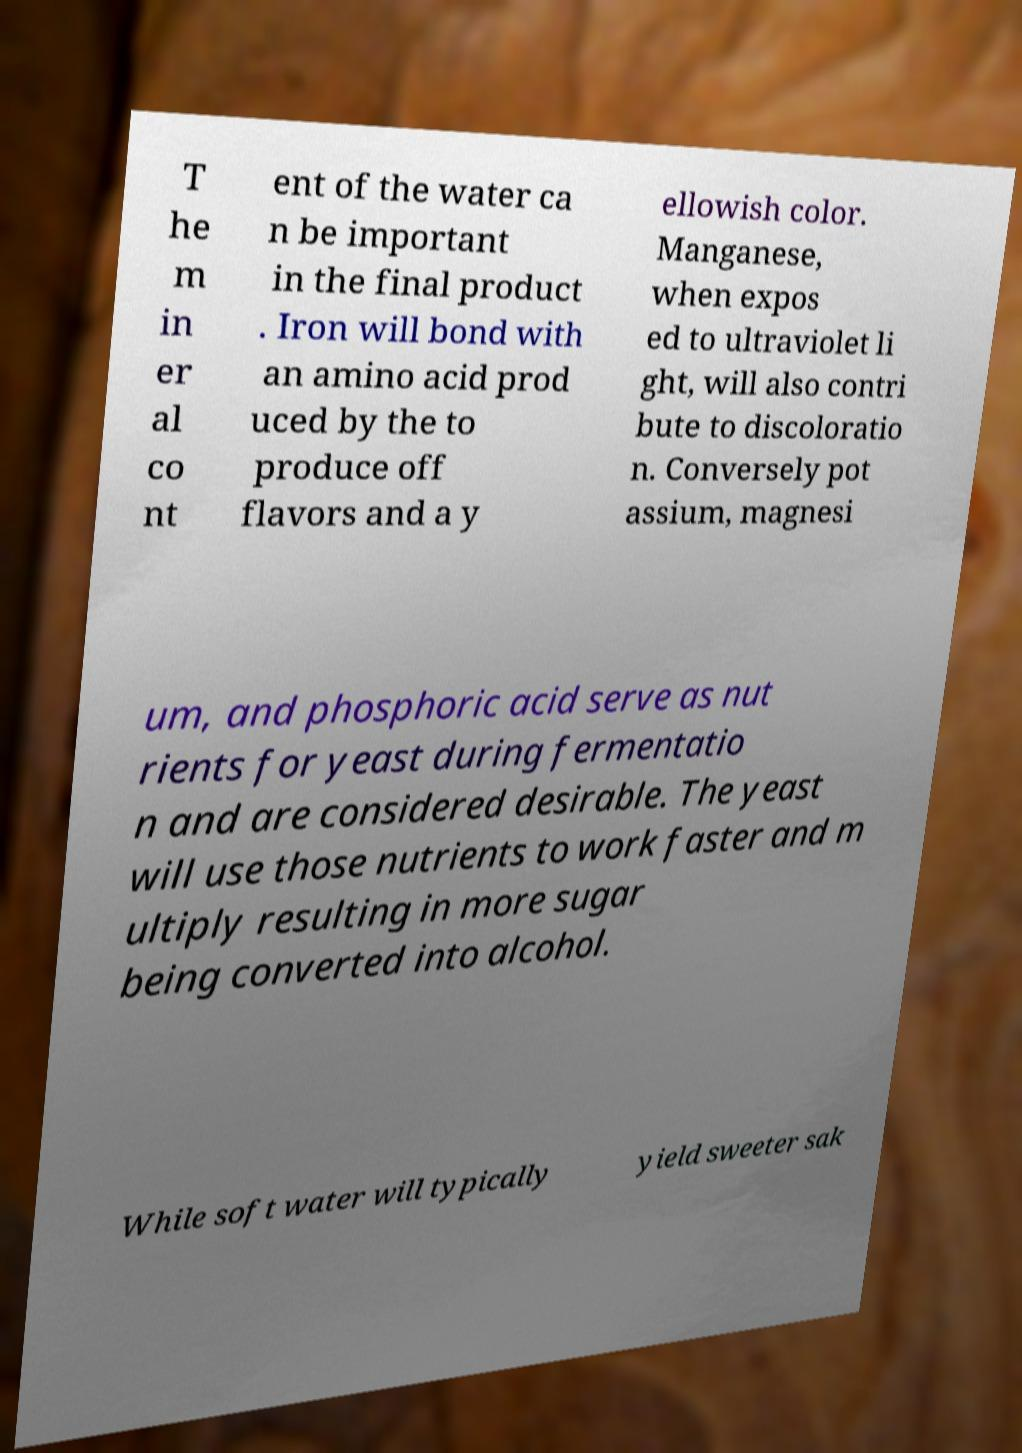Please read and relay the text visible in this image. What does it say? T he m in er al co nt ent of the water ca n be important in the final product . Iron will bond with an amino acid prod uced by the to produce off flavors and a y ellowish color. Manganese, when expos ed to ultraviolet li ght, will also contri bute to discoloratio n. Conversely pot assium, magnesi um, and phosphoric acid serve as nut rients for yeast during fermentatio n and are considered desirable. The yeast will use those nutrients to work faster and m ultiply resulting in more sugar being converted into alcohol. While soft water will typically yield sweeter sak 